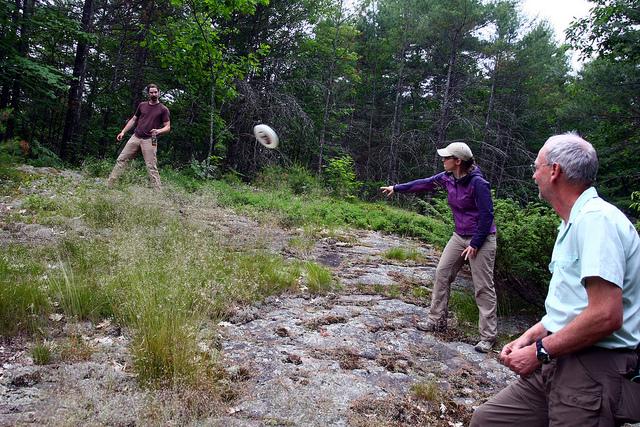Who is he throwing to?
Give a very brief answer. Man. Who is wearing a watch?
Short answer required. Man. Why is there so many trees?
Quick response, please. Forest. Will the man catch the Frisbee?
Give a very brief answer. Yes. 